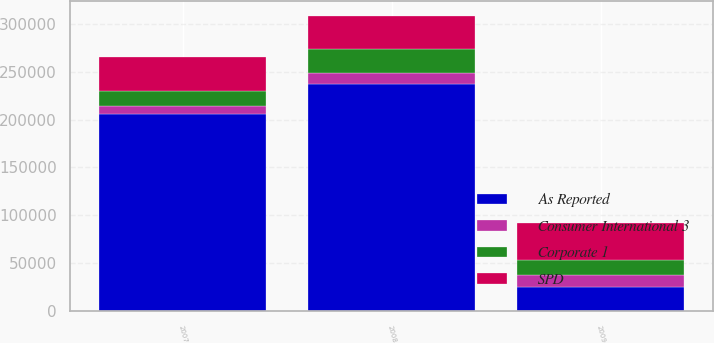Convert chart. <chart><loc_0><loc_0><loc_500><loc_500><stacked_bar_chart><ecel><fcel>2009<fcel>2008<fcel>2007<nl><fcel>As Reported<fcel>25335<fcel>236956<fcel>205688<nl><fcel>SPD<fcel>38562<fcel>34635<fcel>34656<nl><fcel>Corporate 1<fcel>15991<fcel>25335<fcel>16351<nl><fcel>Consumer International 3<fcel>12050<fcel>11334<fcel>8236<nl></chart> 